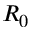<formula> <loc_0><loc_0><loc_500><loc_500>R _ { 0 }</formula> 